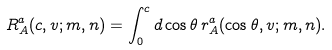Convert formula to latex. <formula><loc_0><loc_0><loc_500><loc_500>R _ { A } ^ { a } ( c , v ; m , n ) = \int _ { 0 } ^ { c } d \cos \theta \, r _ { A } ^ { a } ( \cos \theta , v ; m , n ) .</formula> 